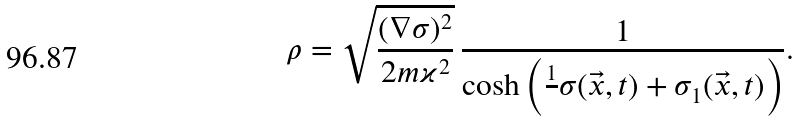<formula> <loc_0><loc_0><loc_500><loc_500>\rho = \sqrt { \frac { ( \nabla \sigma ) ^ { 2 } } { 2 m \varkappa ^ { 2 } } } \, \frac { 1 } { \cosh \left ( \frac { 1 } { } \sigma ( \vec { x } , t ) + \sigma _ { 1 } ( \vec { x } , t ) \right ) } .</formula> 